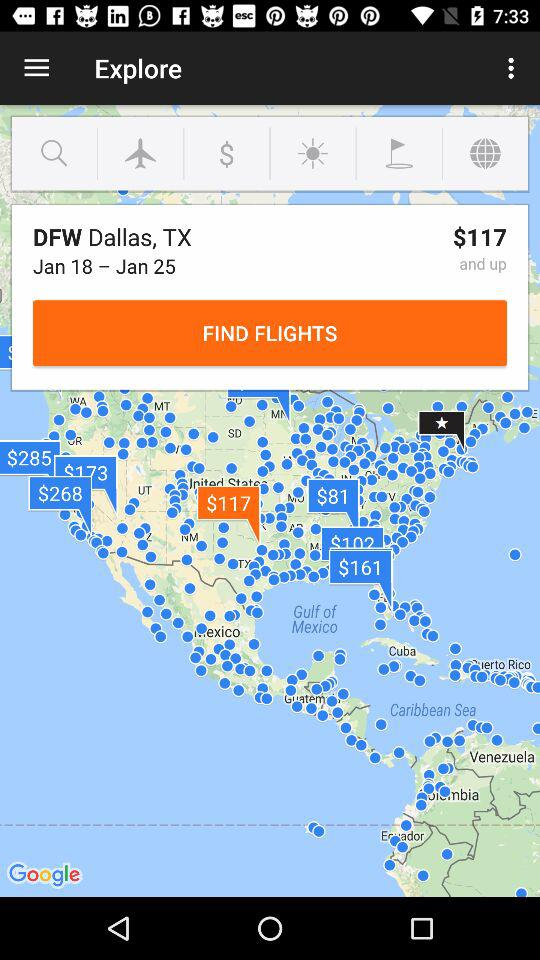How far away is Dallas, TX?
When the provided information is insufficient, respond with <no answer>. <no answer> 